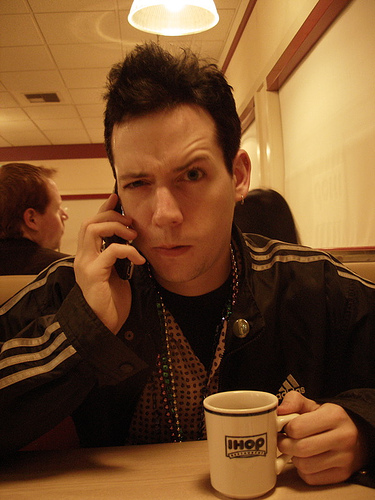Please extract the text content from this image. IHOP adidas 